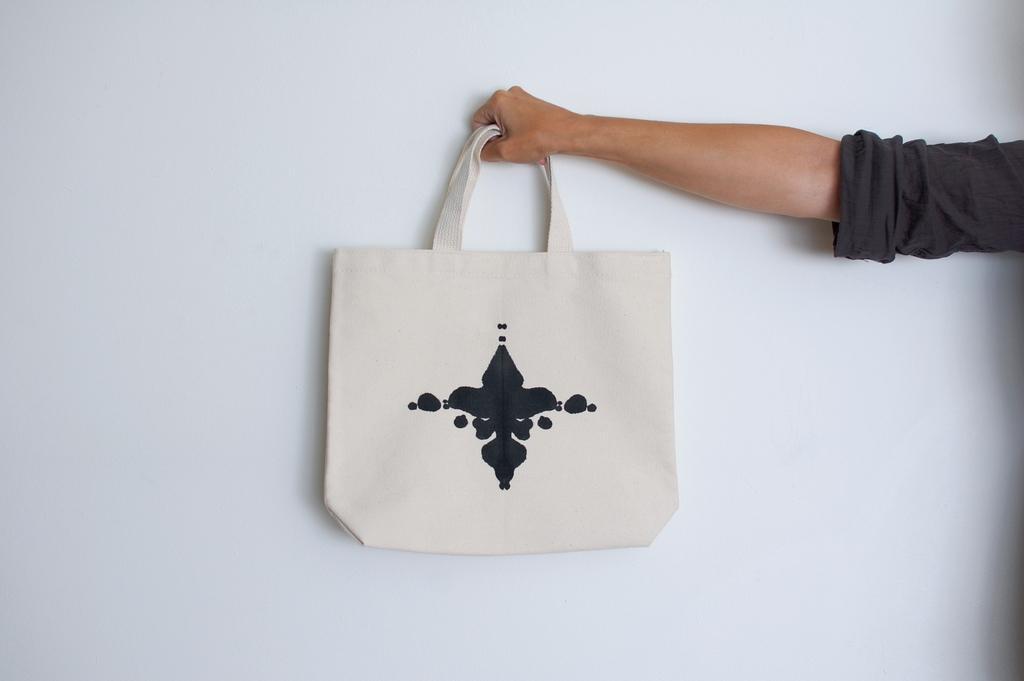Describe this image in one or two sentences. In this picture we can see the human hand holding a bag. 